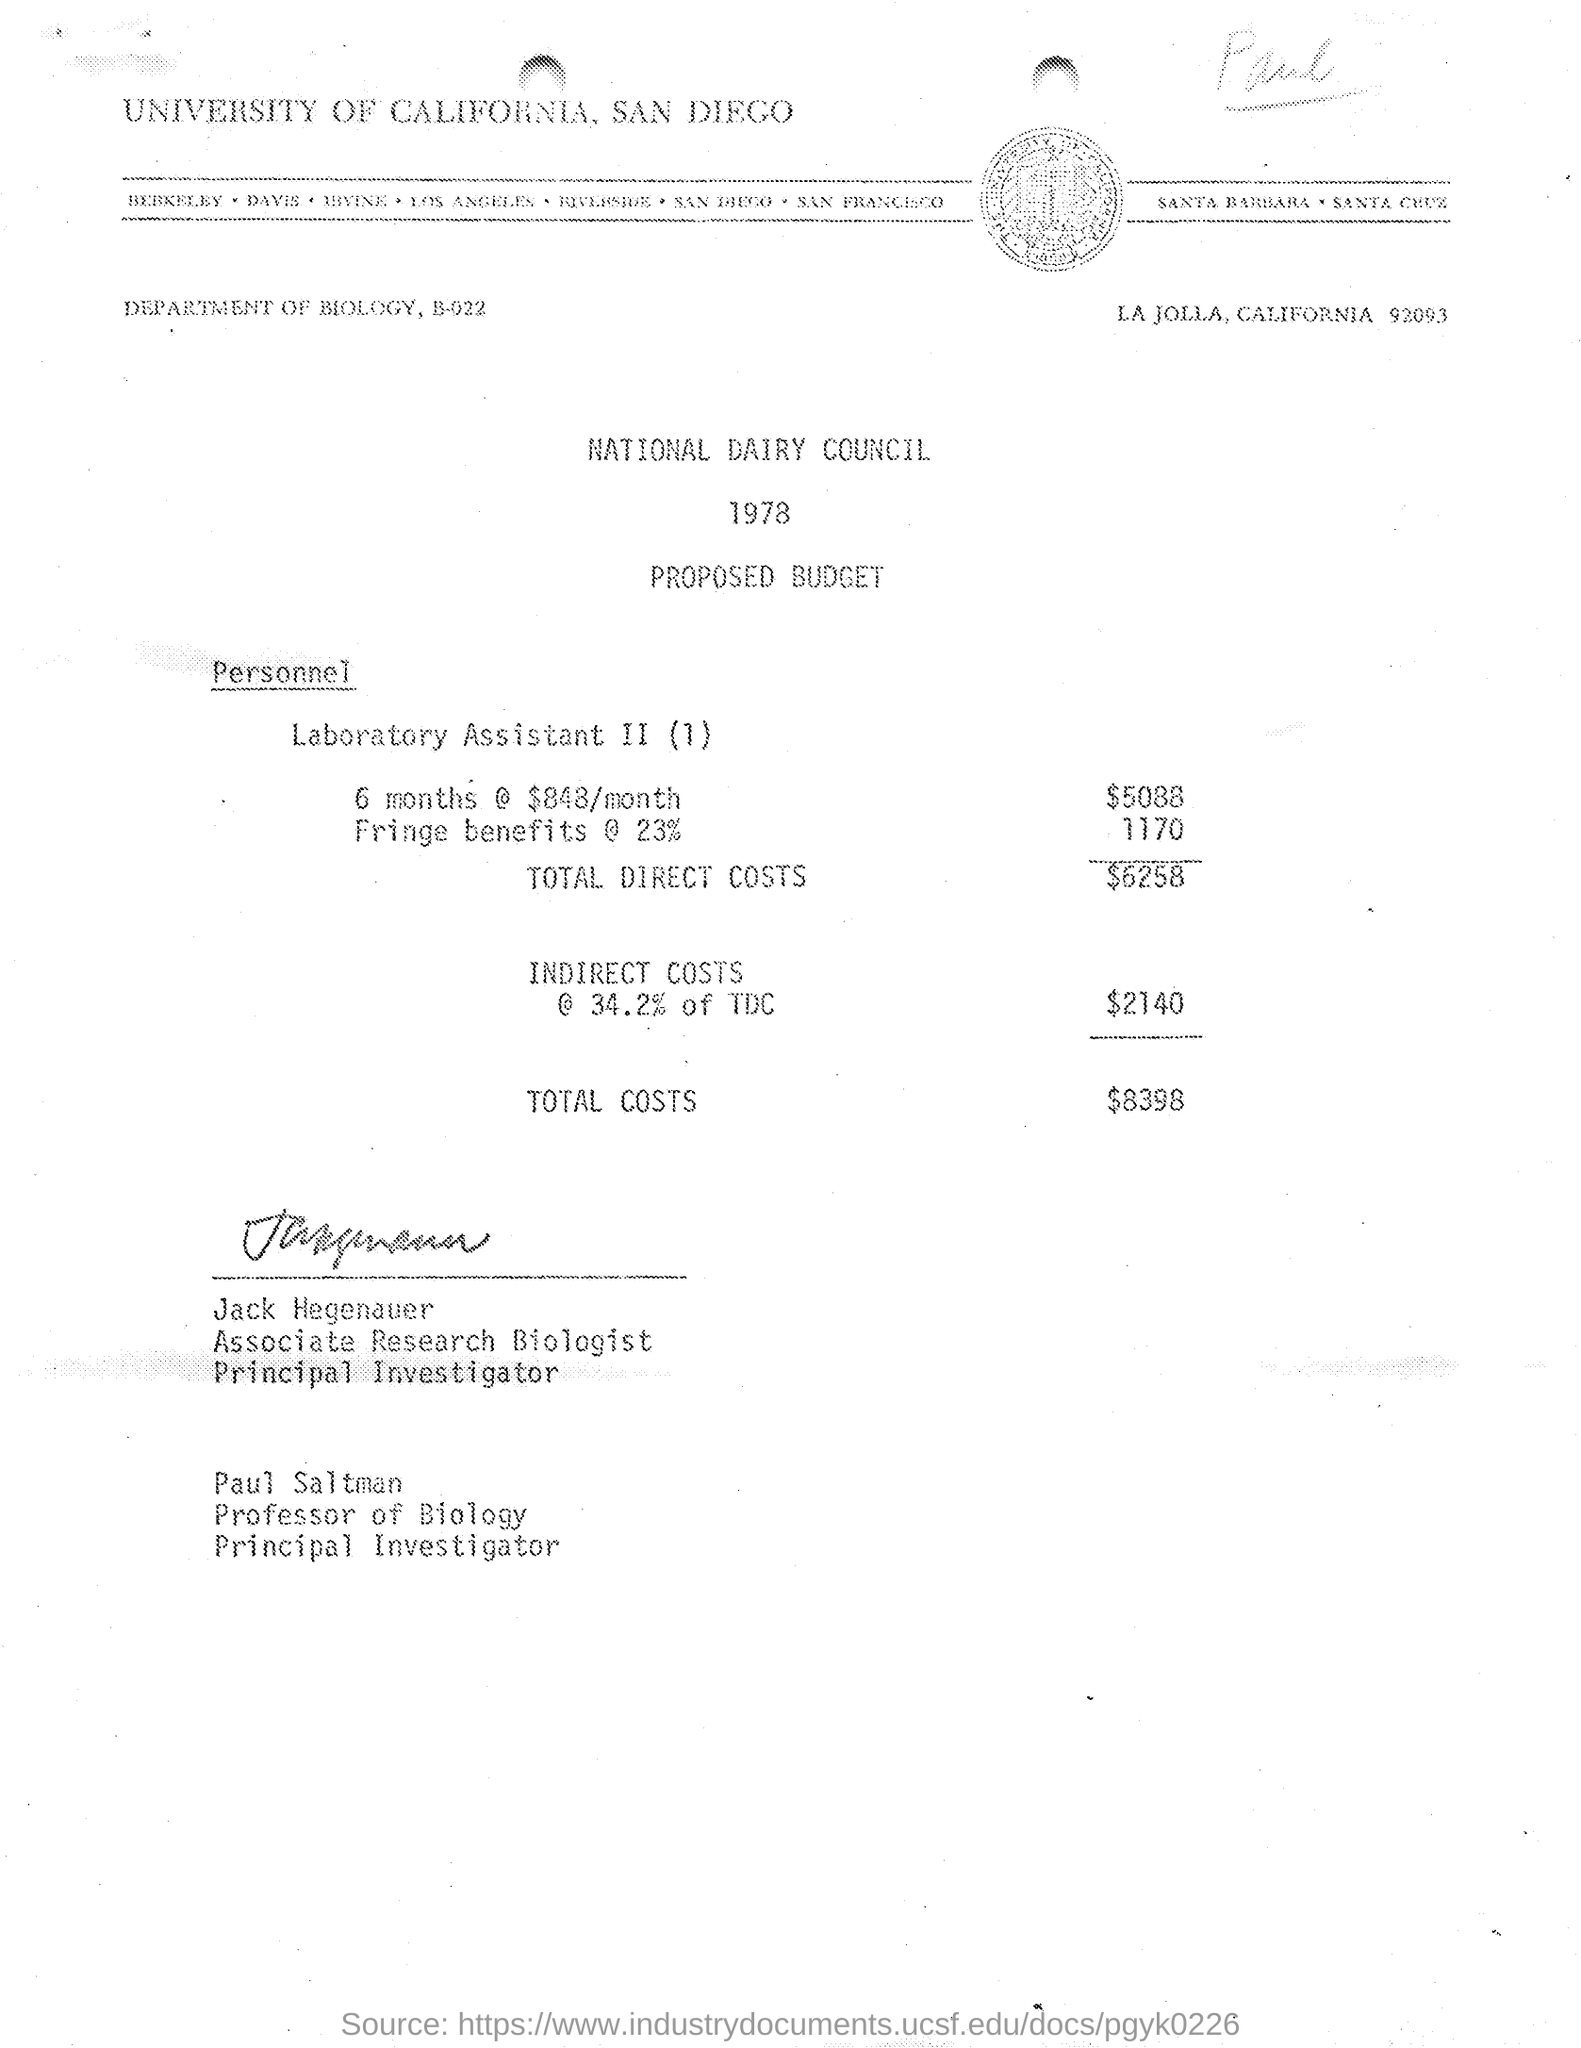What is the budget for Laboratory Assistants for 6 months? The budget for a Laboratory Assistant II position for 6 months is $5,088, not including additional fringe benefits and indirect costs which total $3,910. This brings the total cost for the 6-month period to $8,998, as outlined in the proposed budget by the National Dairy Council for the year 1978. 